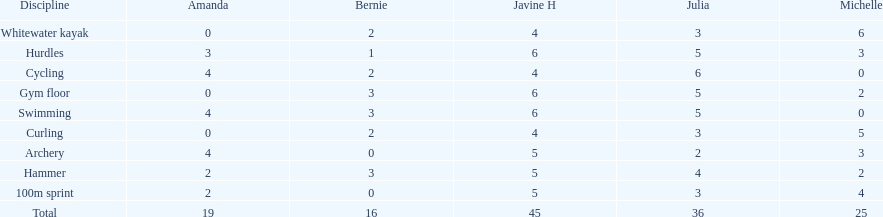Who is the faster runner? Javine H. 